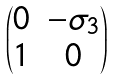Convert formula to latex. <formula><loc_0><loc_0><loc_500><loc_500>\begin{pmatrix} 0 & - \sigma _ { 3 } \\ 1 & 0 \end{pmatrix}</formula> 